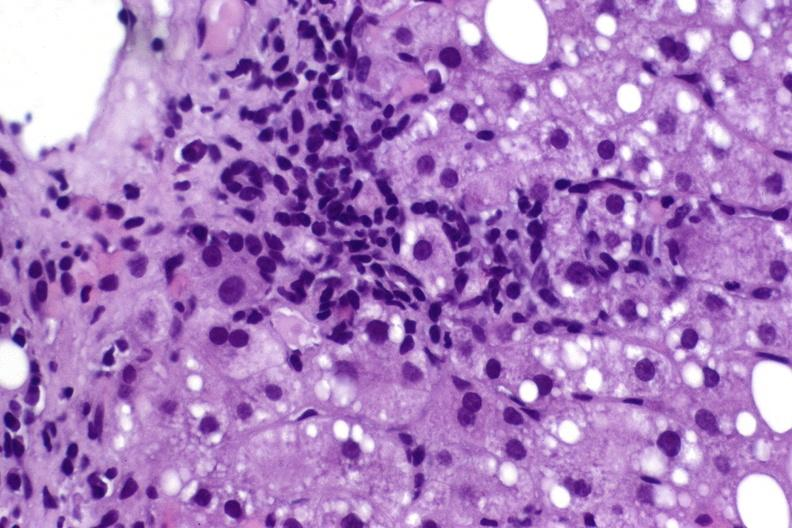what is present?
Answer the question using a single word or phrase. Hepatobiliary 